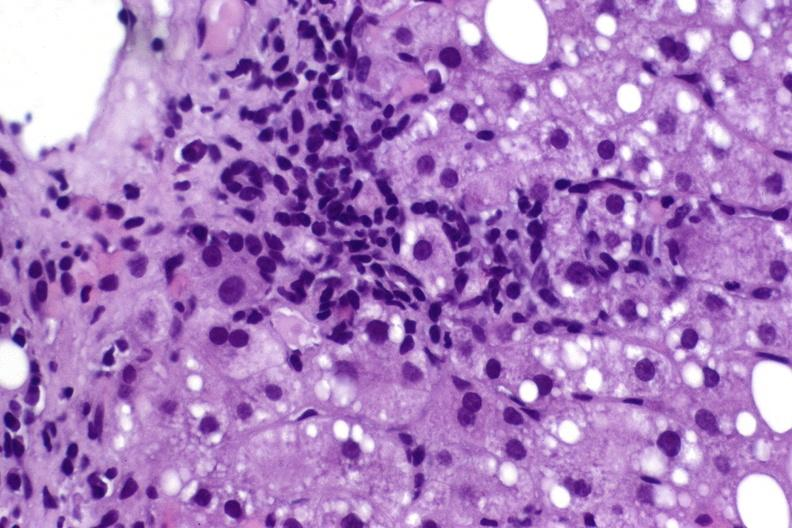what is present?
Answer the question using a single word or phrase. Hepatobiliary 